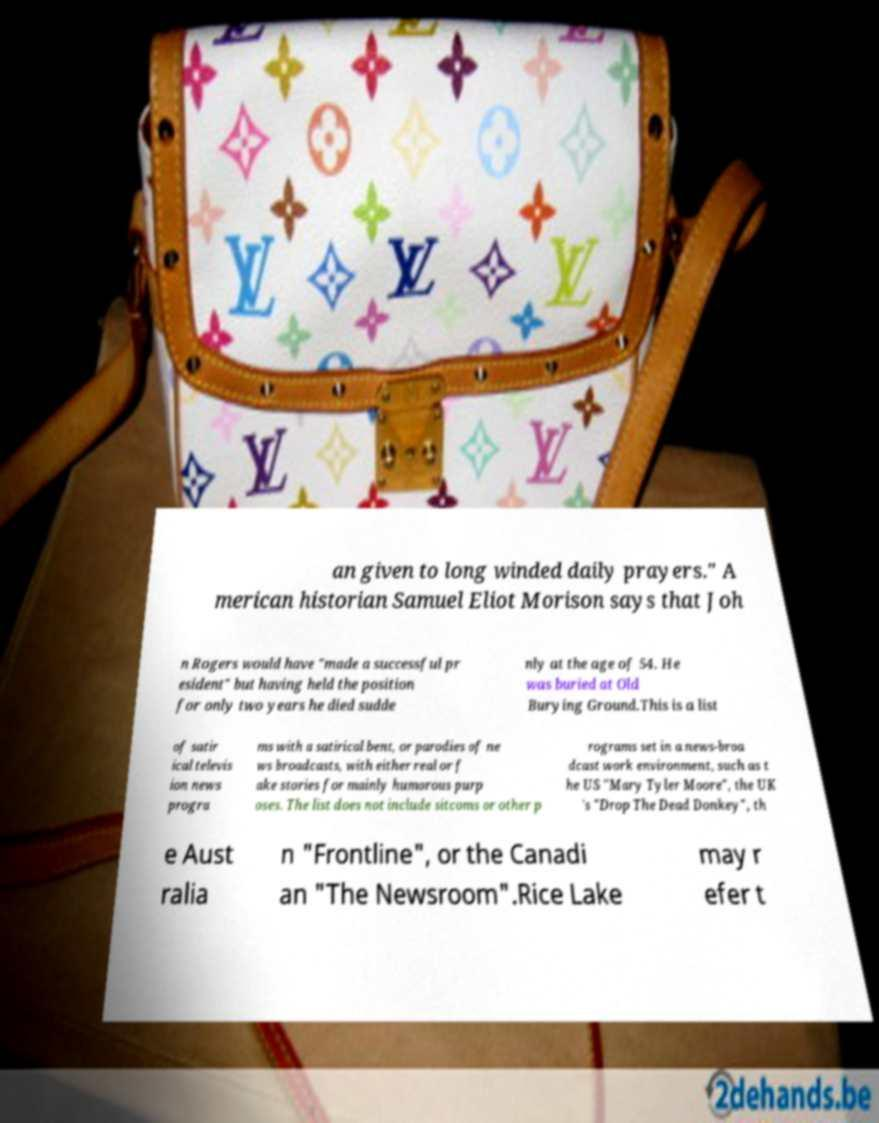I need the written content from this picture converted into text. Can you do that? an given to long winded daily prayers." A merican historian Samuel Eliot Morison says that Joh n Rogers would have "made a successful pr esident" but having held the position for only two years he died sudde nly at the age of 54. He was buried at Old Burying Ground.This is a list of satir ical televis ion news progra ms with a satirical bent, or parodies of ne ws broadcasts, with either real or f ake stories for mainly humorous purp oses. The list does not include sitcoms or other p rograms set in a news-broa dcast work environment, such as t he US "Mary Tyler Moore", the UK 's "Drop The Dead Donkey", th e Aust ralia n "Frontline", or the Canadi an "The Newsroom".Rice Lake may r efer t 